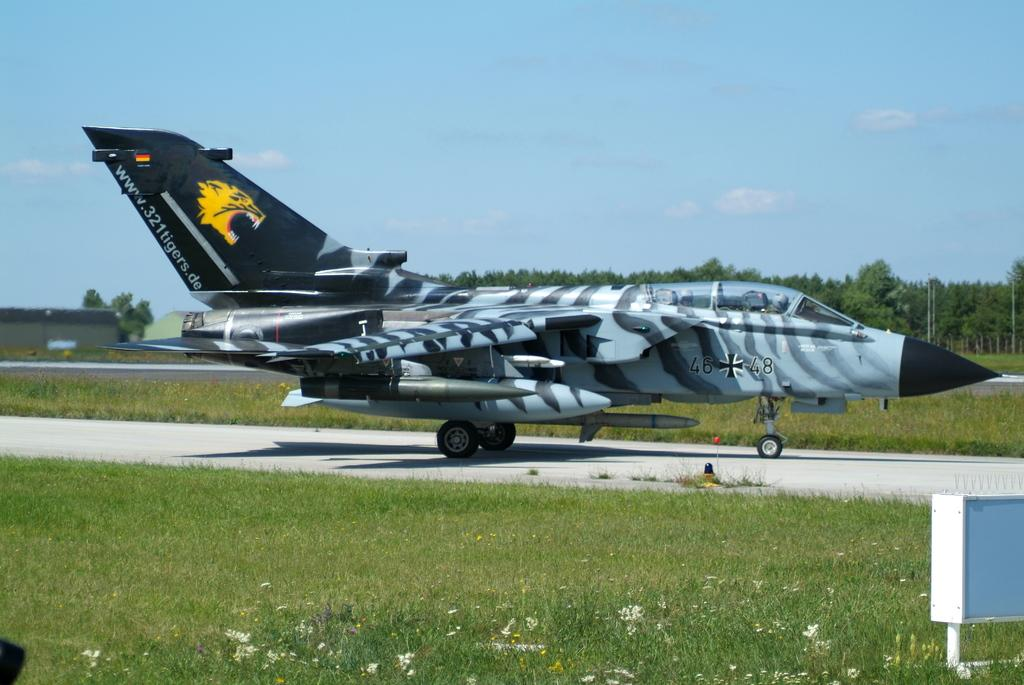<image>
Write a terse but informative summary of the picture. A German fighter plane that is part of the Tigers squad. 